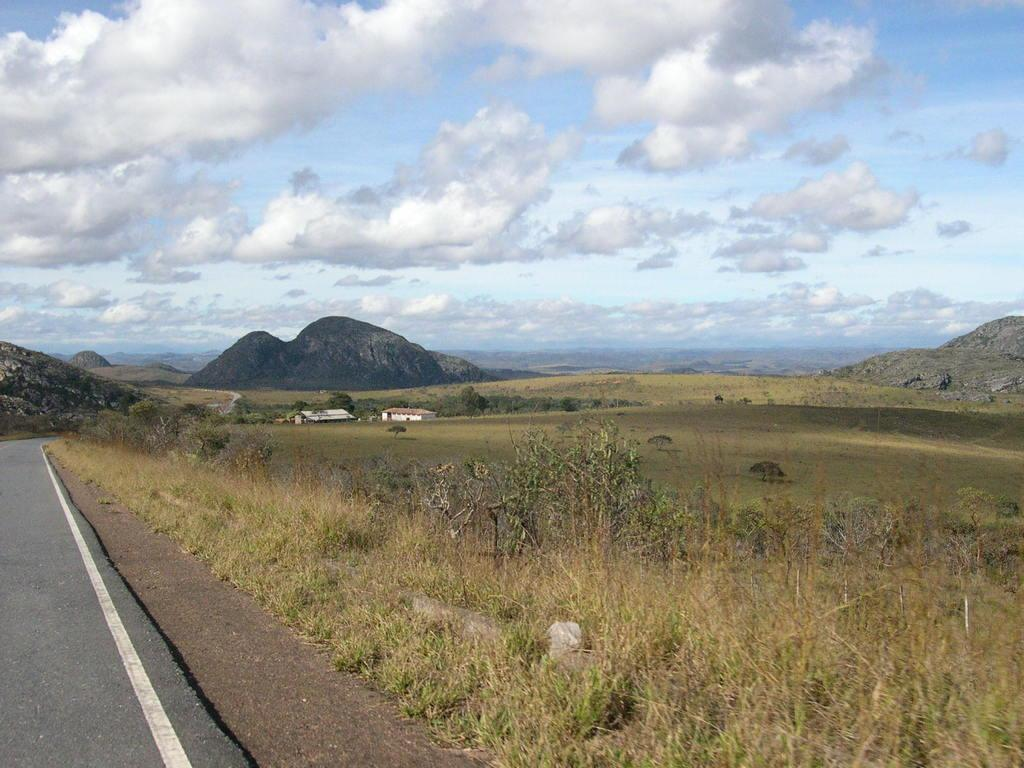What is located on the left side of the image? There is a road on the left side of the image. What can be seen in the background of the image? There are trees, plants, grass, houses, mountains, and clouds in the sky in the background of the image. What type of brick is used to build the question in the image? There is no question present in the image, and therefore no bricks can be associated with it. 